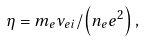Convert formula to latex. <formula><loc_0><loc_0><loc_500><loc_500>\eta = m _ { e } \nu _ { e i } / \left ( { n _ { e } e ^ { 2 } } \right ) ,</formula> 